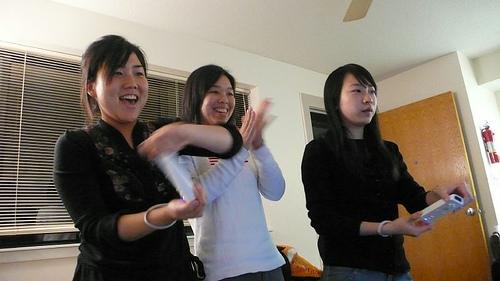Are all of the girls smiling?
Answer briefly. No. Are these girls bisexual?
Answer briefly. No. How many girls are holding video game controllers?
Write a very short answer. 2. 